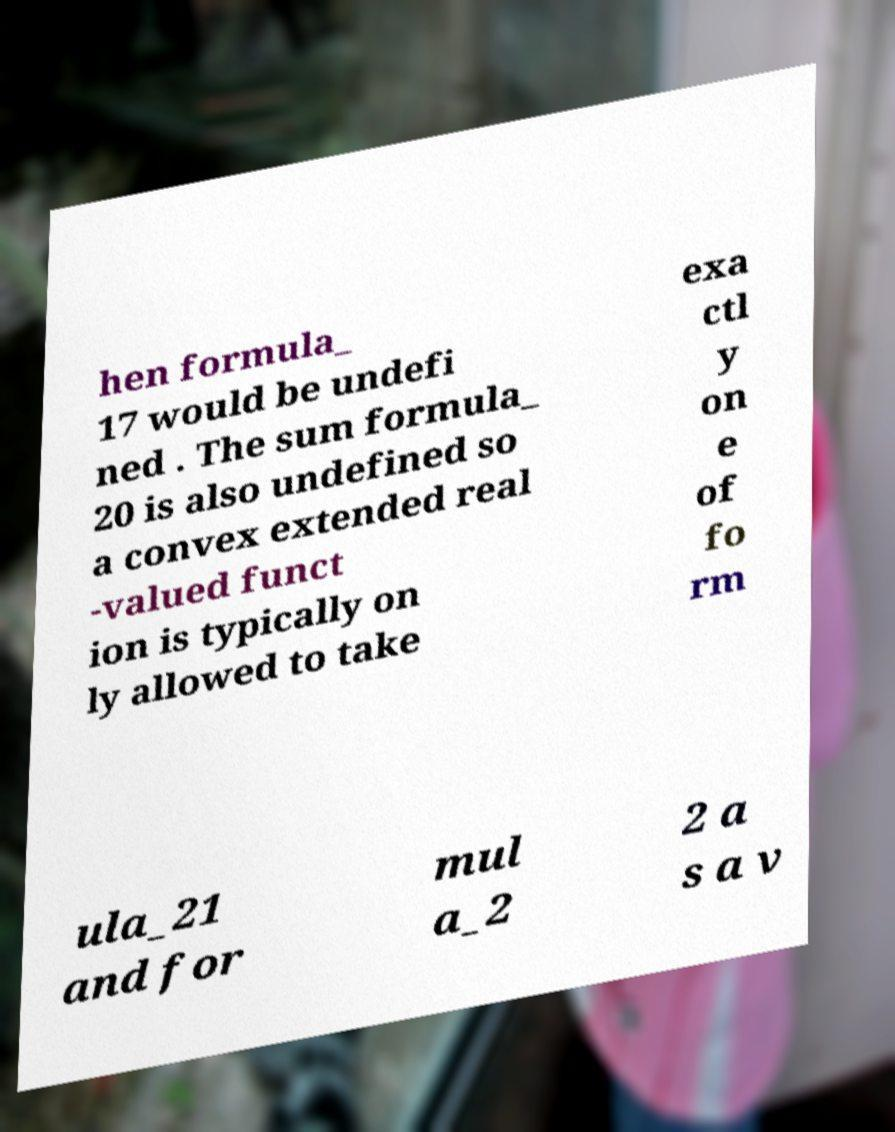Could you extract and type out the text from this image? hen formula_ 17 would be undefi ned . The sum formula_ 20 is also undefined so a convex extended real -valued funct ion is typically on ly allowed to take exa ctl y on e of fo rm ula_21 and for mul a_2 2 a s a v 